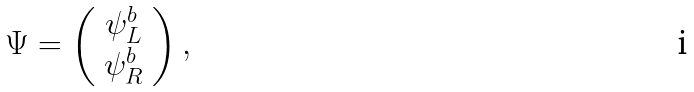<formula> <loc_0><loc_0><loc_500><loc_500>\Psi = \left ( \begin{array} { c } \psi _ { L } ^ { b } \\ \psi _ { R } ^ { b } \end{array} \right ) ,</formula> 